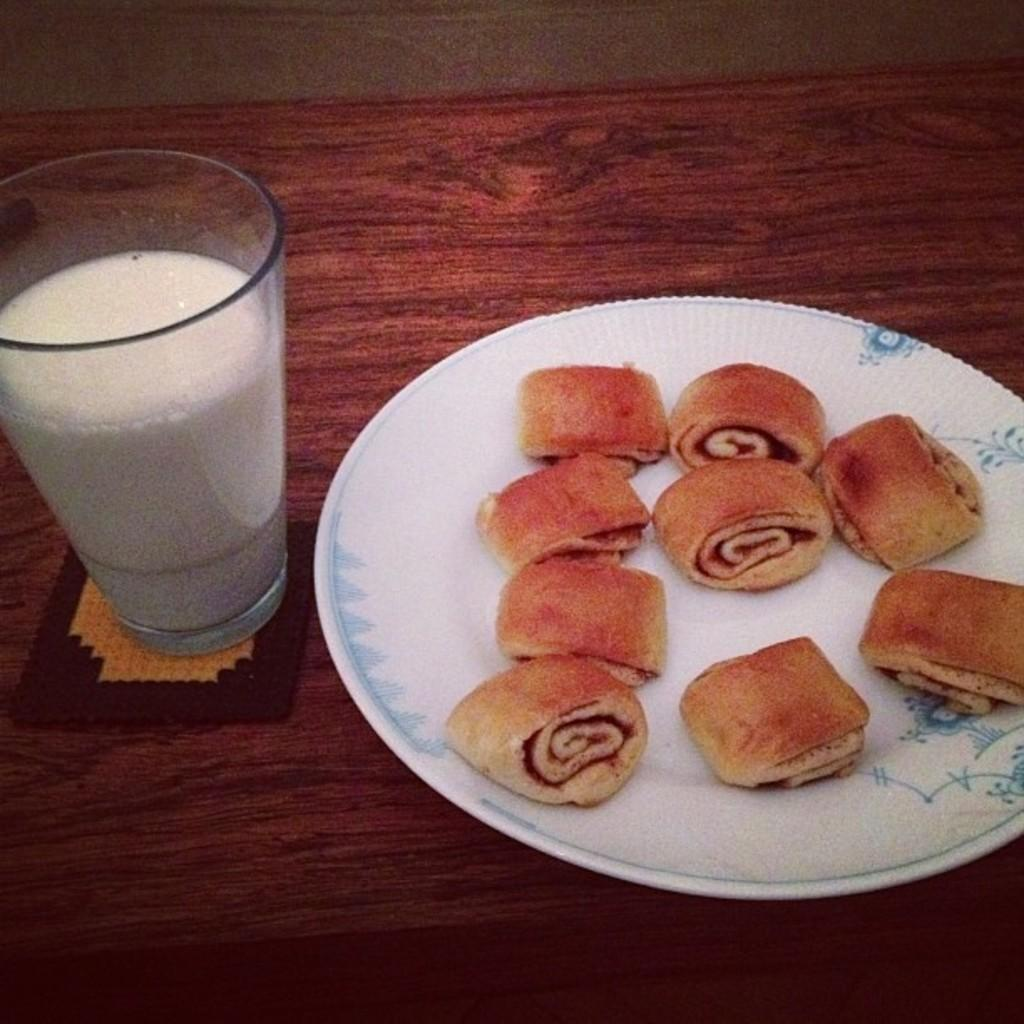What is on the white plate in the image? The plate contains swiss rolls. What is in the glass that is visible in the image? The glass contains milk. What is the material of the table on which the objects are placed? The table is made of wood. What is the color of the wooden table? The table is in brown color. What type of plants can be seen growing on the dinner table in the image? There are no plants visible on the table in the image; it contains a white plate with swiss rolls and a glass with milk. Is there a gate present in the image? There is no gate visible in the image. 